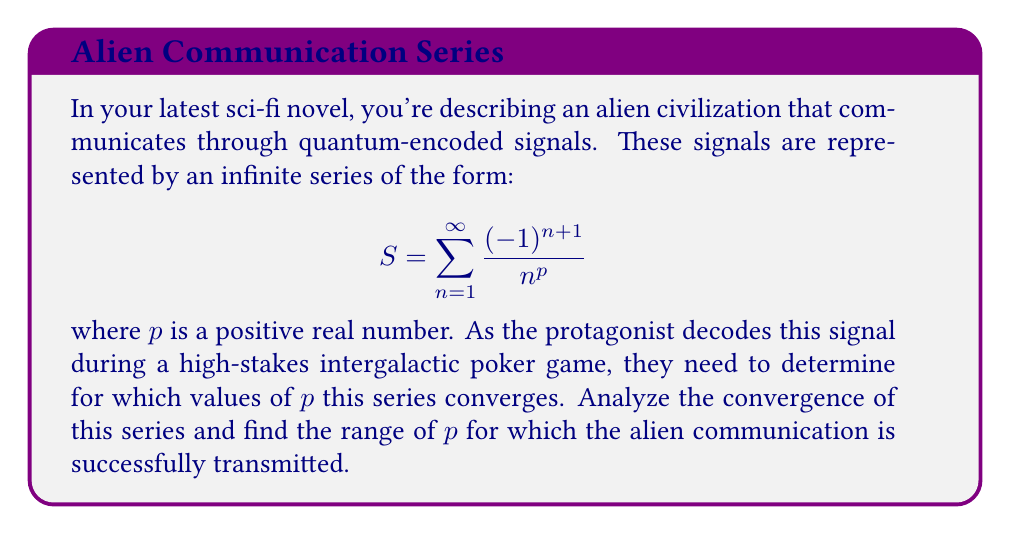Can you solve this math problem? Let's approach this step-by-step:

1) First, we recognize this series as an alternating series due to the $(-1)^{n+1}$ term.

2) For alternating series, we can use the Alternating Series Test, which states that if:
   a) $\lim_{n \to \infty} |a_n| = 0$, and
   b) $|a_{n+1}| \leq |a_n|$ for all $n \geq N$, for some $N$,
   then the series converges.

3) In our case, $a_n = \frac{1}{n^p}$. Let's check these conditions:

   a) $\lim_{n \to \infty} |a_n| = \lim_{n \to \infty} \frac{1}{n^p}$
      This limit is 0 for any $p > 0$.

   b) $|a_{n+1}| \leq |a_n|$ means $\frac{1}{(n+1)^p} \leq \frac{1}{n^p}$
      This is true for any $p > 0$ and $n \geq 1$.

4) Therefore, by the Alternating Series Test, this series converges for all $p > 0$.

5) However, we can say more. When $p > 1$, the series not only converges but is absolutely convergent. We can show this using the p-series test:

   $\sum_{n=1}^{\infty} \frac{1}{n^p}$ converges when $p > 1$.

6) When $0 < p \leq 1$, the series is conditionally convergent (converges, but not absolutely).

Therefore, the alien communication signal converges for all $p > 0$, with absolute convergence for $p > 1$ and conditional convergence for $0 < p \leq 1$.
Answer: The series converges for all $p > 0$. 